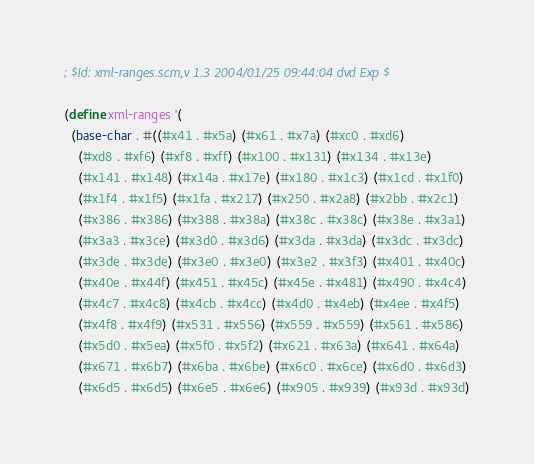Convert code to text. <code><loc_0><loc_0><loc_500><loc_500><_Scheme_>; $Id: xml-ranges.scm,v 1.3 2004/01/25 09:44:04 dvd Exp $

(define xml-ranges '(
  (base-char . #((#x41 . #x5a) (#x61 . #x7a) (#xc0 . #xd6)
    (#xd8 . #xf6) (#xf8 . #xff) (#x100 . #x131) (#x134 . #x13e)
    (#x141 . #x148) (#x14a . #x17e) (#x180 . #x1c3) (#x1cd . #x1f0)
    (#x1f4 . #x1f5) (#x1fa . #x217) (#x250 . #x2a8) (#x2bb . #x2c1)
    (#x386 . #x386) (#x388 . #x38a) (#x38c . #x38c) (#x38e . #x3a1)
    (#x3a3 . #x3ce) (#x3d0 . #x3d6) (#x3da . #x3da) (#x3dc . #x3dc)
    (#x3de . #x3de) (#x3e0 . #x3e0) (#x3e2 . #x3f3) (#x401 . #x40c)
    (#x40e . #x44f) (#x451 . #x45c) (#x45e . #x481) (#x490 . #x4c4)
    (#x4c7 . #x4c8) (#x4cb . #x4cc) (#x4d0 . #x4eb) (#x4ee . #x4f5)
    (#x4f8 . #x4f9) (#x531 . #x556) (#x559 . #x559) (#x561 . #x586)
    (#x5d0 . #x5ea) (#x5f0 . #x5f2) (#x621 . #x63a) (#x641 . #x64a)
    (#x671 . #x6b7) (#x6ba . #x6be) (#x6c0 . #x6ce) (#x6d0 . #x6d3)
    (#x6d5 . #x6d5) (#x6e5 . #x6e6) (#x905 . #x939) (#x93d . #x93d)</code> 